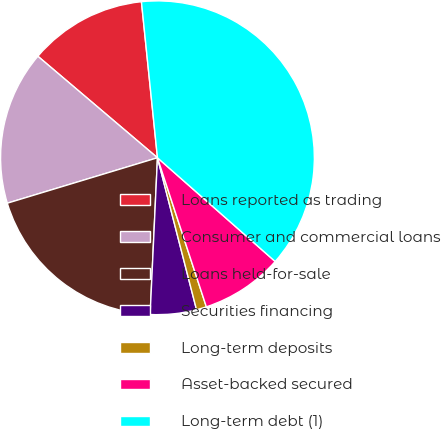Convert chart to OTSL. <chart><loc_0><loc_0><loc_500><loc_500><pie_chart><fcel>Loans reported as trading<fcel>Consumer and commercial loans<fcel>Loans held-for-sale<fcel>Securities financing<fcel>Long-term deposits<fcel>Asset-backed secured<fcel>Long-term debt (1)<nl><fcel>12.17%<fcel>15.88%<fcel>19.58%<fcel>4.75%<fcel>1.04%<fcel>8.46%<fcel>38.13%<nl></chart> 